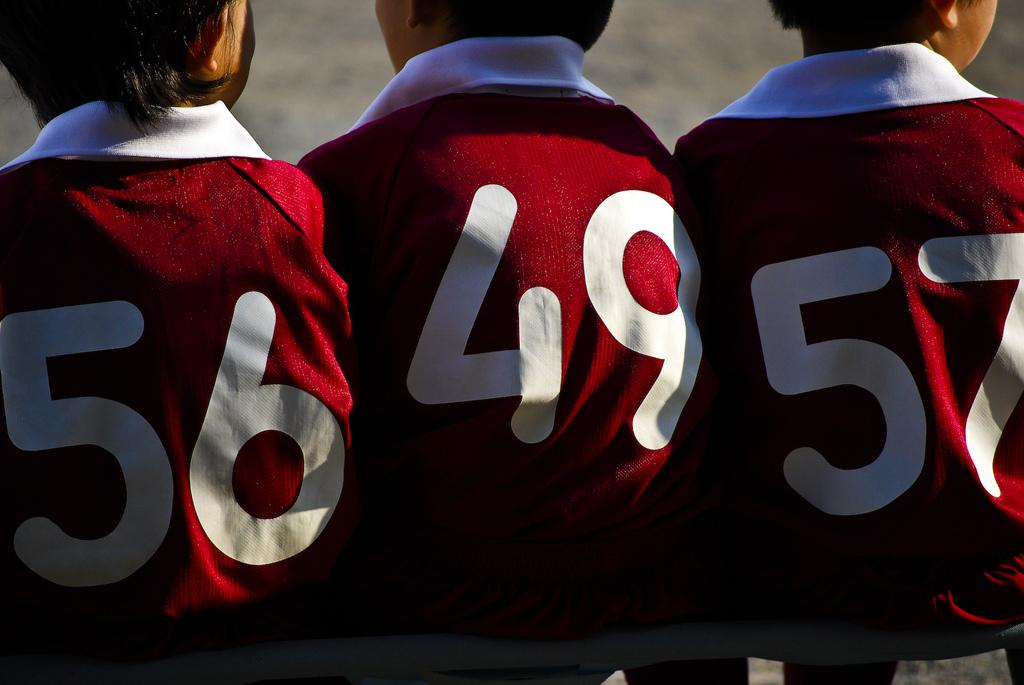Who or what is present in the image? There are people in the image. What distinguishing feature can be observed on the people's clothes? The people have numbers on their clothes. What type of loaf is being used to zip up the train in the image? There is no loaf or train present in the image. 